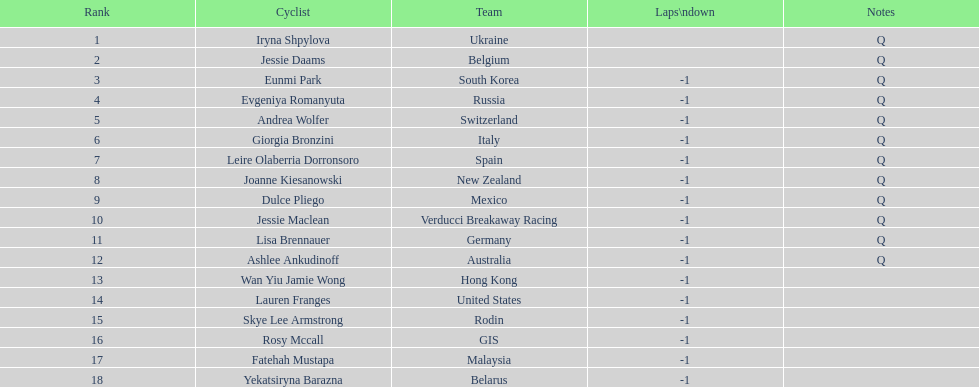Which team is mentioned before belgium? Ukraine. 